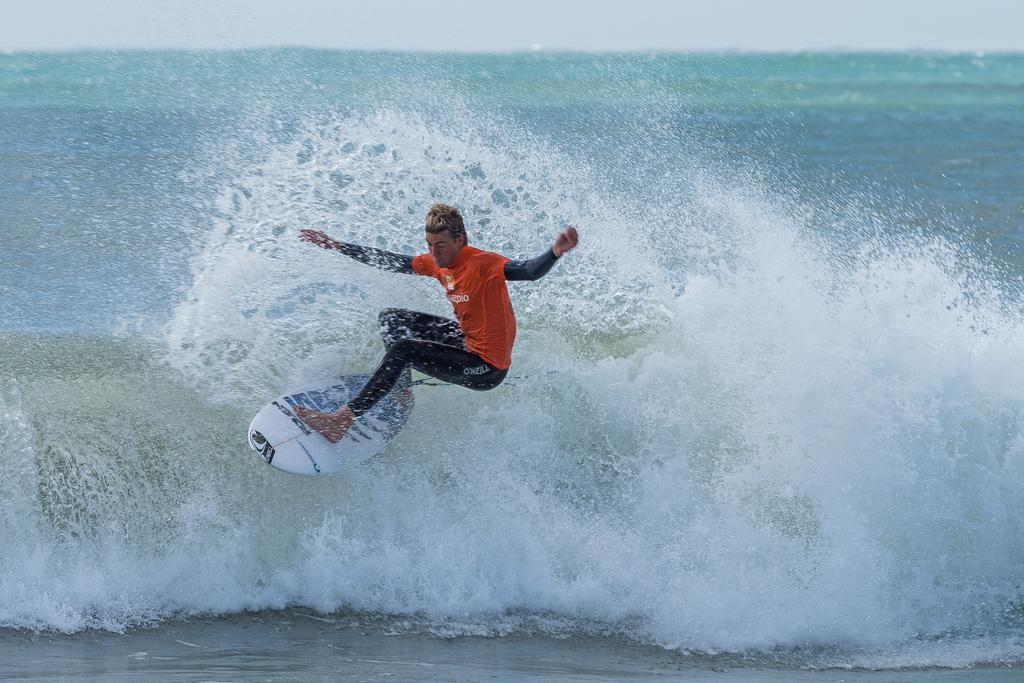Provide a one-sentence caption for the provided image. A man surfs with O'neill on his black pants. 